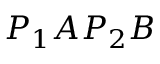Convert formula to latex. <formula><loc_0><loc_0><loc_500><loc_500>P _ { 1 } A P _ { 2 } B</formula> 